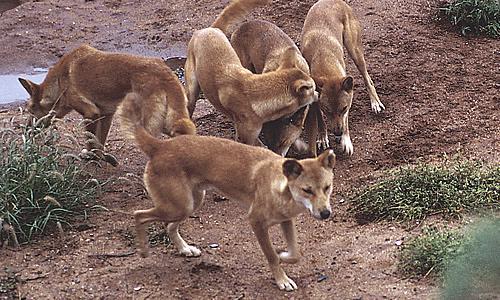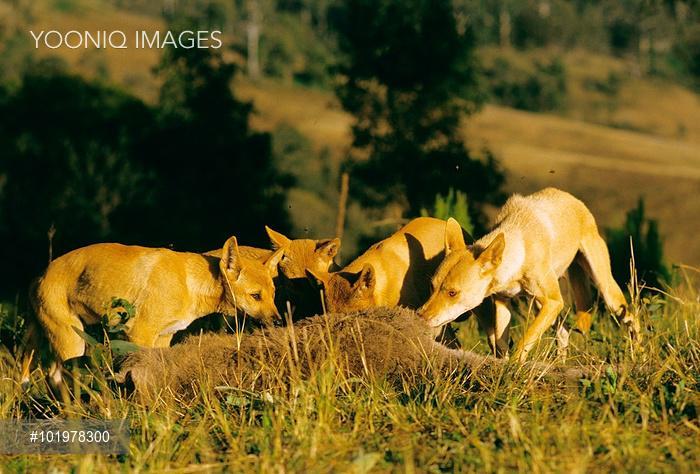The first image is the image on the left, the second image is the image on the right. For the images shown, is this caption "None of the animals are lying down." true? Answer yes or no. Yes. The first image is the image on the left, the second image is the image on the right. Evaluate the accuracy of this statement regarding the images: "There are 3 dogs in one of the images.". Is it true? Answer yes or no. No. 